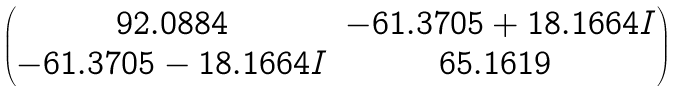Convert formula to latex. <formula><loc_0><loc_0><loc_500><loc_500>\begin{pmatrix} 9 2 . 0 8 8 4 & - 6 1 . 3 7 0 5 + 1 8 . 1 6 6 4 I \\ - 6 1 . 3 7 0 5 - 1 8 . 1 6 6 4 I & 6 5 . 1 6 1 9 \ \end{pmatrix}</formula> 